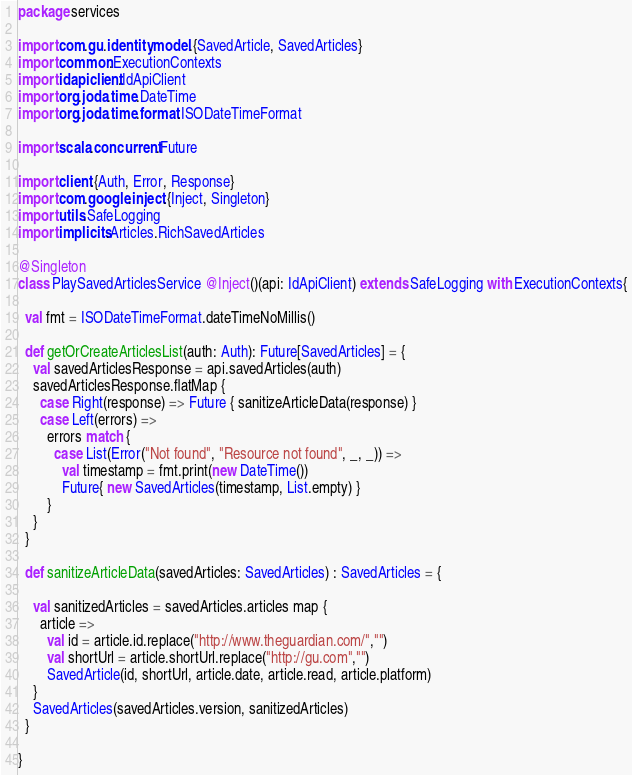Convert code to text. <code><loc_0><loc_0><loc_500><loc_500><_Scala_>package services

import com.gu.identity.model.{SavedArticle, SavedArticles}
import common.ExecutionContexts
import idapiclient.IdApiClient
import org.joda.time.DateTime
import org.joda.time.format.ISODateTimeFormat

import scala.concurrent.Future

import client.{Auth, Error, Response}
import com.google.inject.{Inject, Singleton}
import utils.SafeLogging
import implicits.Articles.RichSavedArticles

@Singleton
class PlaySavedArticlesService @Inject()(api: IdApiClient) extends SafeLogging with ExecutionContexts{

  val fmt = ISODateTimeFormat.dateTimeNoMillis()

  def getOrCreateArticlesList(auth: Auth): Future[SavedArticles] = {
    val savedArticlesResponse = api.savedArticles(auth)
    savedArticlesResponse.flatMap {
      case Right(response) => Future { sanitizeArticleData(response) }
      case Left(errors) =>
        errors match {
          case List(Error("Not found", "Resource not found", _, _)) =>
            val timestamp = fmt.print(new DateTime())
            Future{ new SavedArticles(timestamp, List.empty) }
        }
    }
  }

  def sanitizeArticleData(savedArticles: SavedArticles) : SavedArticles = {

    val sanitizedArticles = savedArticles.articles map {
      article =>
        val id = article.id.replace("http://www.theguardian.com/","")
        val shortUrl = article.shortUrl.replace("http://gu.com","")
        SavedArticle(id, shortUrl, article.date, article.read, article.platform)
    }
    SavedArticles(savedArticles.version, sanitizedArticles)
  }

}
</code> 